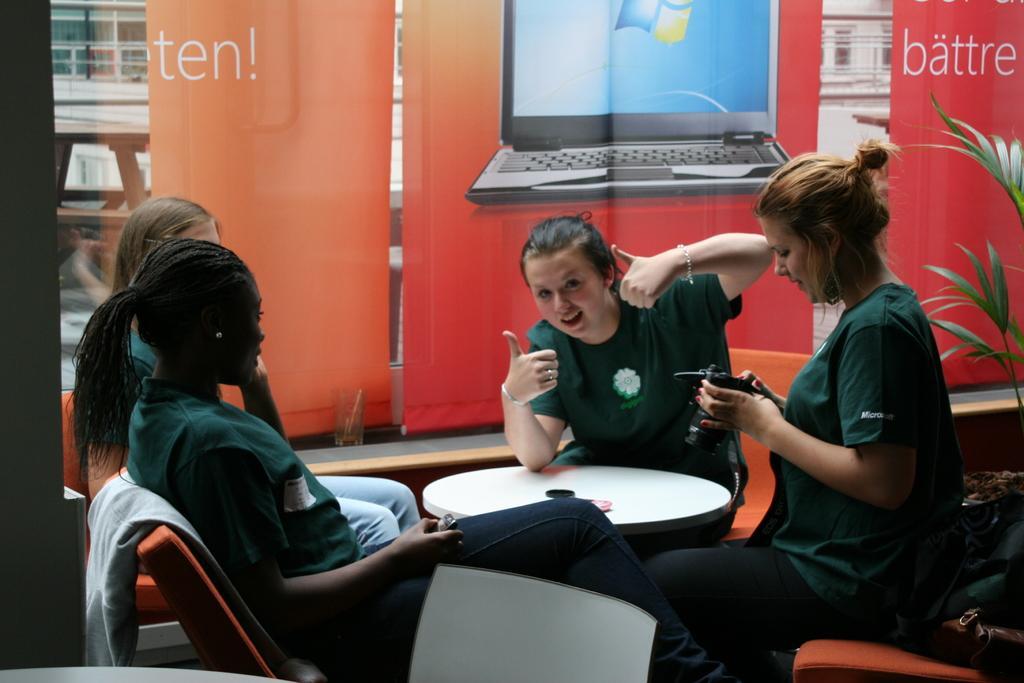Please provide a concise description of this image. In this picture there is a girl, smiling and giving a pose into the camera. Beside there is a another girl looking into the phone. On the left side there are two girl sitting and watching them. In the background there is a red color rolling banner. 